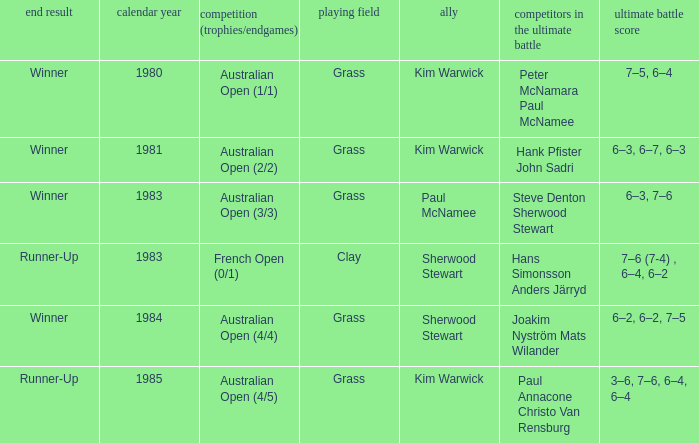What championship was played in 1981? Australian Open (2/2). 